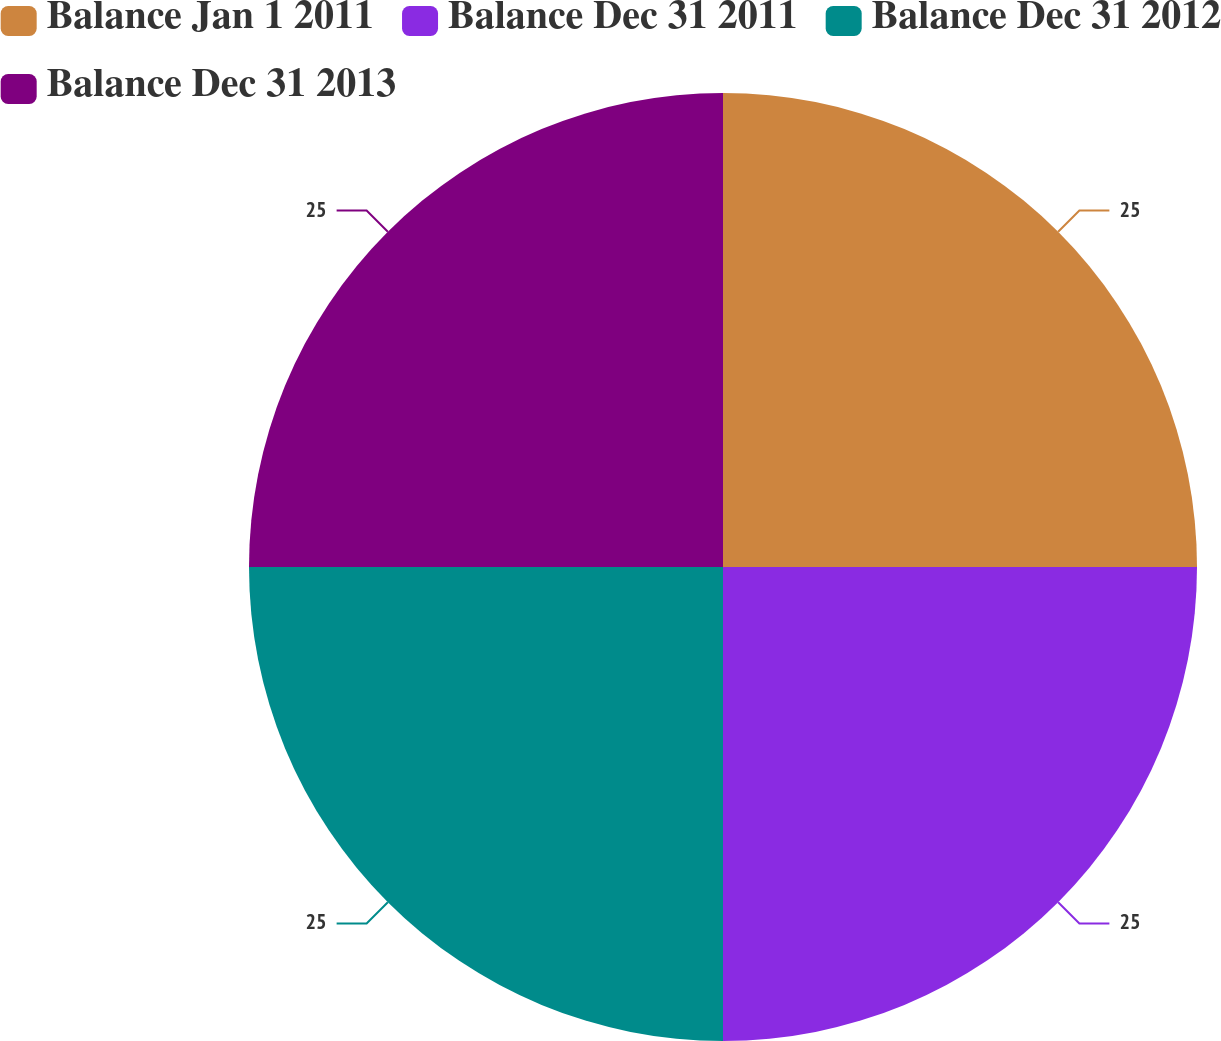<chart> <loc_0><loc_0><loc_500><loc_500><pie_chart><fcel>Balance Jan 1 2011<fcel>Balance Dec 31 2011<fcel>Balance Dec 31 2012<fcel>Balance Dec 31 2013<nl><fcel>25.0%<fcel>25.0%<fcel>25.0%<fcel>25.0%<nl></chart> 